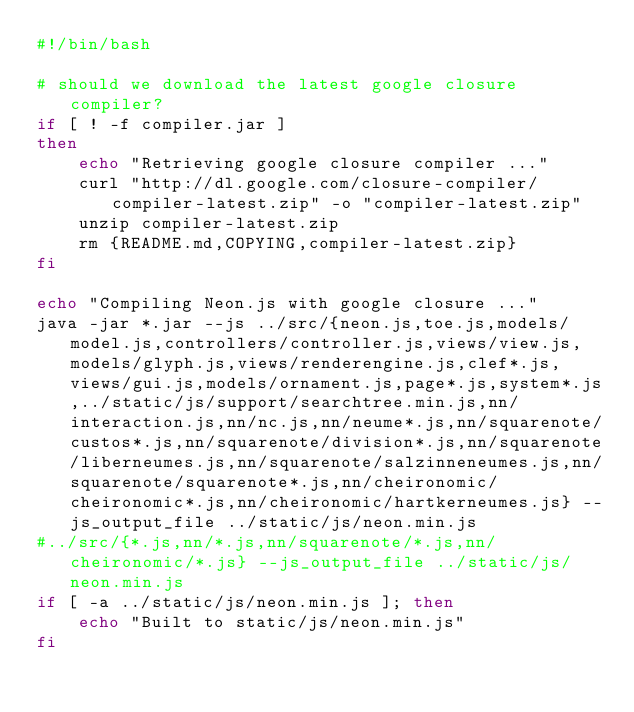<code> <loc_0><loc_0><loc_500><loc_500><_Bash_>#!/bin/bash

# should we download the latest google closure compiler?
if [ ! -f compiler.jar ]
then
    echo "Retrieving google closure compiler ..."
    curl "http://dl.google.com/closure-compiler/compiler-latest.zip" -o "compiler-latest.zip"
    unzip compiler-latest.zip
    rm {README.md,COPYING,compiler-latest.zip}
fi

echo "Compiling Neon.js with google closure ..."
java -jar *.jar --js ../src/{neon.js,toe.js,models/model.js,controllers/controller.js,views/view.js,models/glyph.js,views/renderengine.js,clef*.js,views/gui.js,models/ornament.js,page*.js,system*.js,../static/js/support/searchtree.min.js,nn/interaction.js,nn/nc.js,nn/neume*.js,nn/squarenote/custos*.js,nn/squarenote/division*.js,nn/squarenote/liberneumes.js,nn/squarenote/salzinneneumes.js,nn/squarenote/squarenote*.js,nn/cheironomic/cheironomic*.js,nn/cheironomic/hartkerneumes.js} --js_output_file ../static/js/neon.min.js
#../src/{*.js,nn/*.js,nn/squarenote/*.js,nn/cheironomic/*.js} --js_output_file ../static/js/neon.min.js
if [ -a ../static/js/neon.min.js ]; then
    echo "Built to static/js/neon.min.js"
fi
</code> 